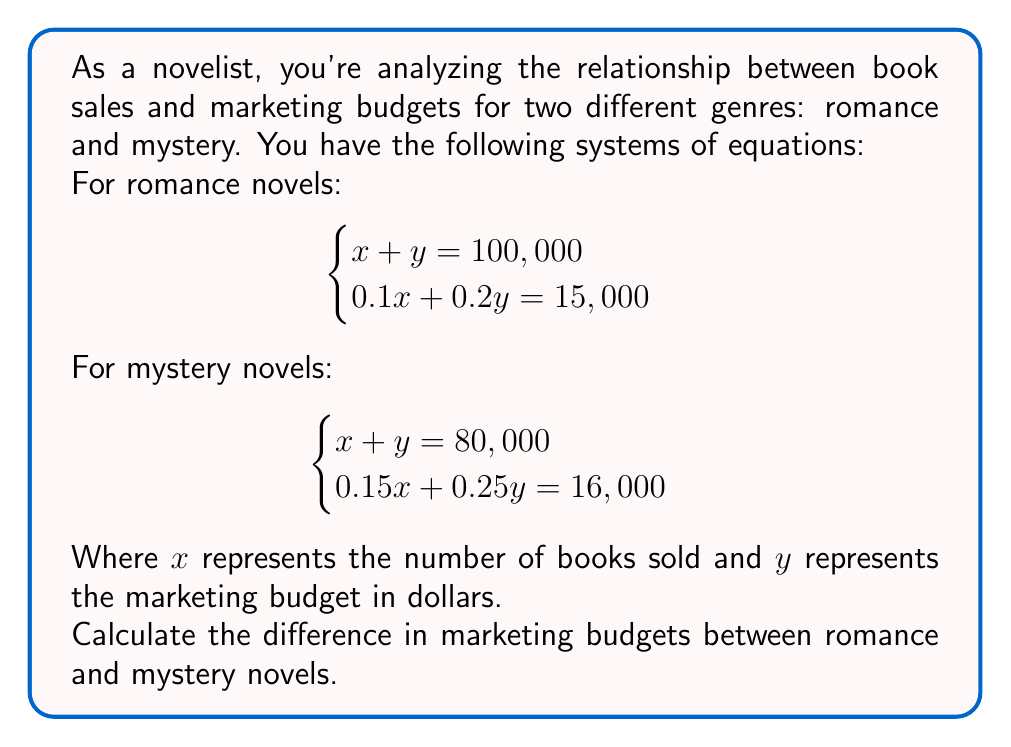What is the answer to this math problem? Let's solve this problem step by step for both genres:

1. For romance novels:
   $$\begin{cases}
   x + y = 100,000 \quad (1)\\
   0.1x + 0.2y = 15,000 \quad (2)
   \end{cases}$$

   Multiply equation (1) by 0.1:
   $$0.1x + 0.1y = 10,000 \quad (3)$$

   Subtract (3) from (2):
   $$0.1y = 5,000$$
   $$y = 50,000$$

   Substitute y in equation (1):
   $$x + 50,000 = 100,000$$
   $$x = 50,000$$

2. For mystery novels:
   $$\begin{cases}
   x + y = 80,000 \quad (4)\\
   0.15x + 0.25y = 16,000 \quad (5)
   \end{cases}$$

   Multiply equation (4) by 0.15:
   $$0.15x + 0.15y = 12,000 \quad (6)$$

   Subtract (6) from (5):
   $$0.1y = 4,000$$
   $$y = 40,000$$

   Substitute y in equation (4):
   $$x + 40,000 = 80,000$$
   $$x = 40,000$$

3. Calculate the difference in marketing budgets:
   Romance marketing budget: $50,000
   Mystery marketing budget: $40,000
   Difference: $50,000 - $40,000 = $10,000
Answer: $10,000 